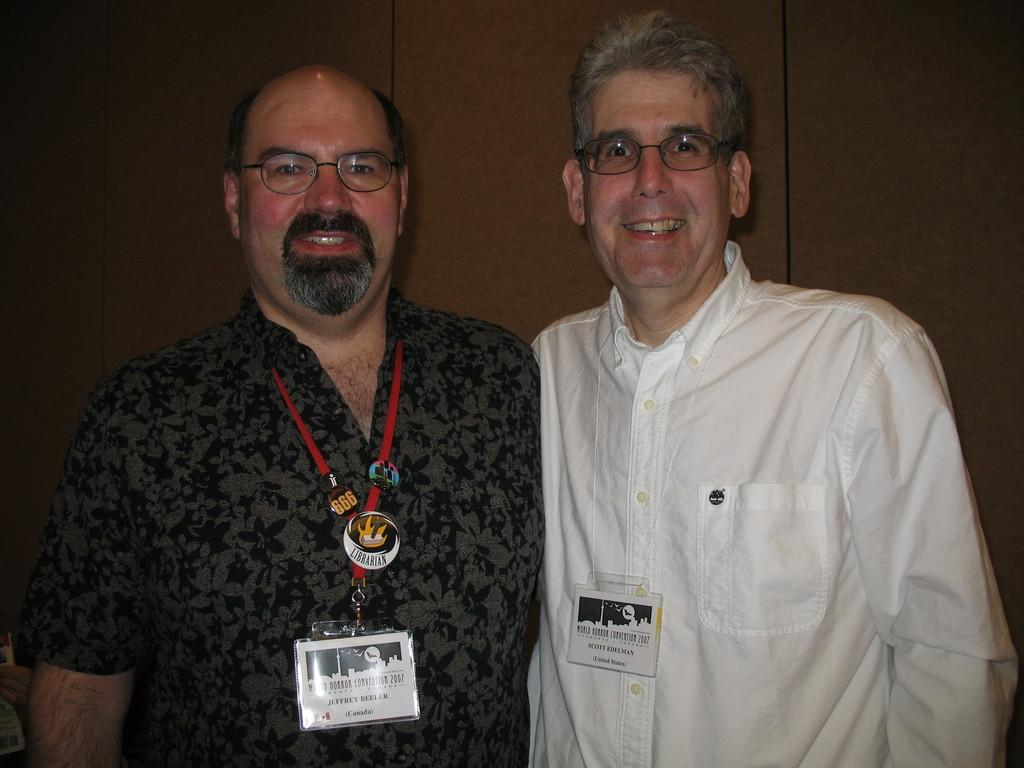How many people are in the image? There are two men in the image. What are the men wearing that is visible in the image? The men are wearing access cards with text on them. What is visible behind the men in the image? There is a wall visible behind the men. What type of watch is the man on the left wearing in the image? There is no watch visible on either man in the image. 